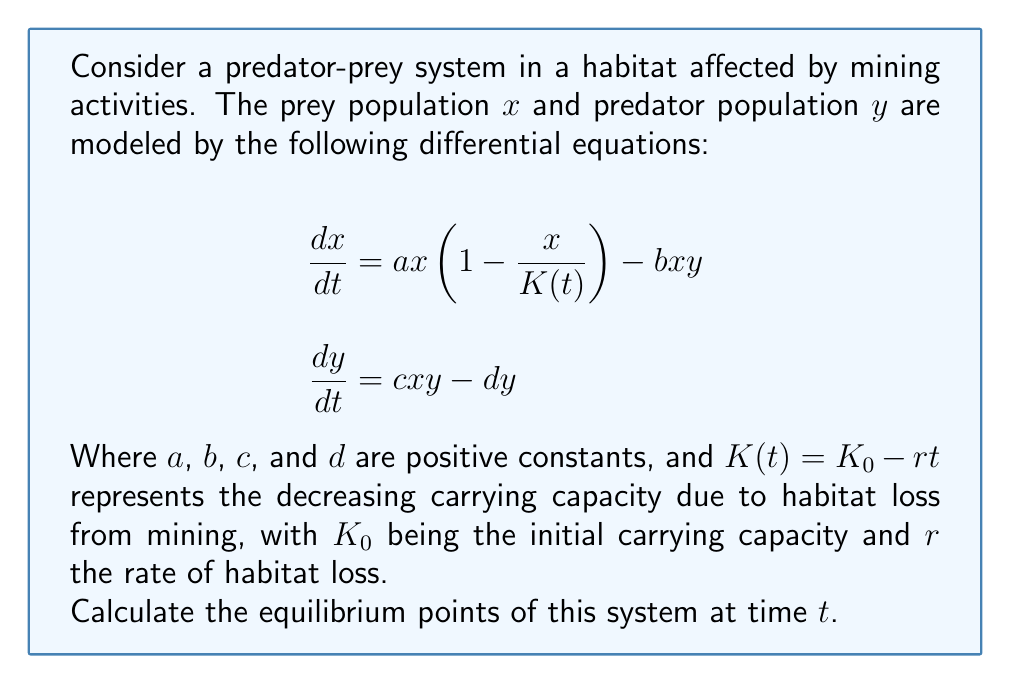What is the answer to this math problem? To find the equilibrium points, we set both equations equal to zero and solve for $x$ and $y$:

1) Set $\frac{dx}{dt} = 0$ and $\frac{dy}{dt} = 0$:

   $$ax(1-\frac{x}{K(t)}) - bxy = 0$$
   $$cxy - dy = 0$$

2) From the second equation:
   $$y = 0$$ or $$x = \frac{d}{c}$$

3) If $y = 0$, substituting into the first equation:
   $$ax(1-\frac{x}{K(t)}) = 0$$
   So, $x = 0$ or $x = K(t) = K_0 - rt$

4) If $x = \frac{d}{c}$, substituting into the first equation:
   $$a\frac{d}{c}(1-\frac{\frac{d}{c}}{K(t)}) - b\frac{d}{c}y = 0$$
   Solving for $y$:
   $$y = \frac{a}{b}(1-\frac{d}{cK(t)}) = \frac{a}{b}(1-\frac{d}{c(K_0 - rt)})$$

5) Therefore, the equilibrium points are:
   $(0, 0)$
   $(K_0 - rt, 0)$
   $(\frac{d}{c}, \frac{a}{b}(1-\frac{d}{c(K_0 - rt)}))$
Answer: $(0, 0)$, $(K_0 - rt, 0)$, $(\frac{d}{c}, \frac{a}{b}(1-\frac{d}{c(K_0 - rt)}))$ 